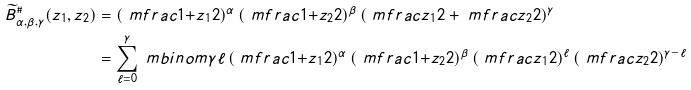Convert formula to latex. <formula><loc_0><loc_0><loc_500><loc_500>\widetilde { B } ^ { \# } _ { \alpha , \beta , \gamma } ( z _ { 1 } , z _ { 2 } ) & = \left ( \ m f r a c { 1 { + } z _ { 1 } } { 2 } \right ) ^ { \alpha } \left ( \ m f r a c { 1 { + } z _ { 2 } } { 2 } \right ) ^ { \beta } \left ( \ m f r a c { z _ { 1 } } { 2 } + \ m f r a c { z _ { 2 } } { 2 } \right ) ^ { \gamma } \\ & = \sum _ { \ell = 0 } ^ { \gamma } \ m b i n o m { \gamma } { \ell } \left ( \ m f r a c { 1 { + } z _ { 1 } } { 2 } \right ) ^ { \alpha } \left ( \ m f r a c { 1 { + } z _ { 2 } } { 2 } \right ) ^ { \beta } \left ( \ m f r a c { z _ { 1 } } { 2 } \right ) ^ { \ell } \left ( \ m f r a c { z _ { 2 } } { 2 } \right ) ^ { \gamma - \ell }</formula> 